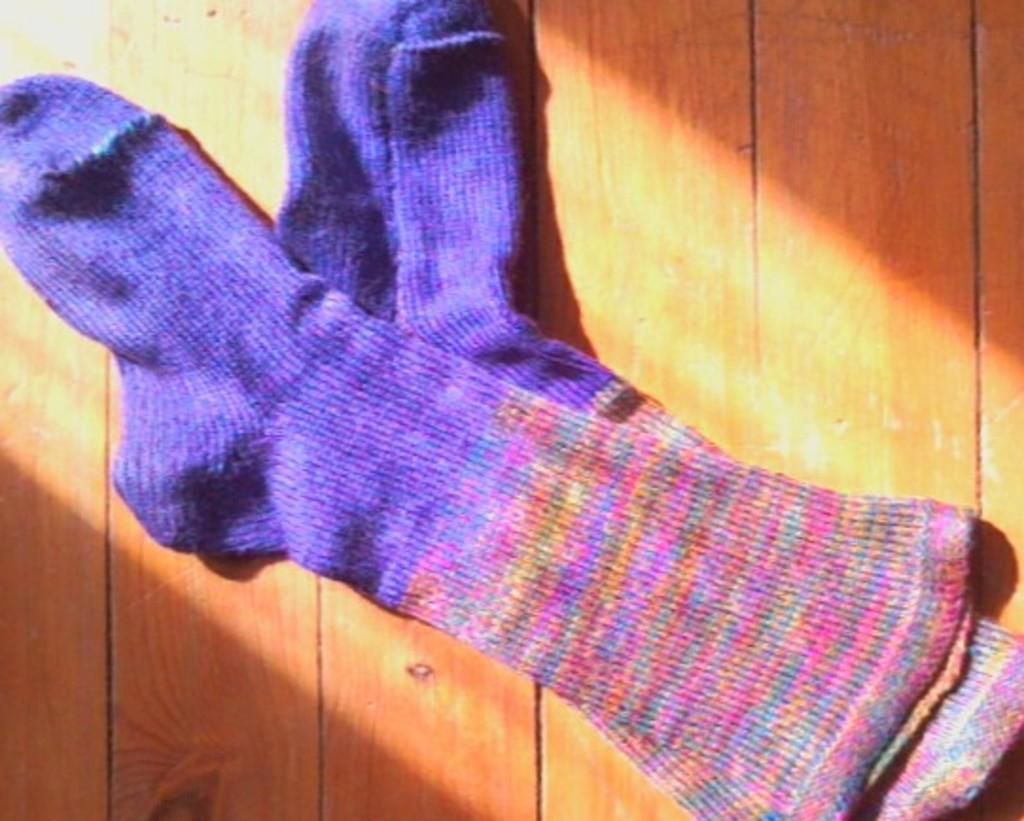How many socks are in the image? There are two socks in the image. What colors are the socks? One sock is violet in color, and the other sock is pink in color. What type of surface are the socks placed on? The socks are on a wooden surface. What type of needle is used to sew the socks together in the image? There is no needle present in the image, nor are the socks sewn together. 